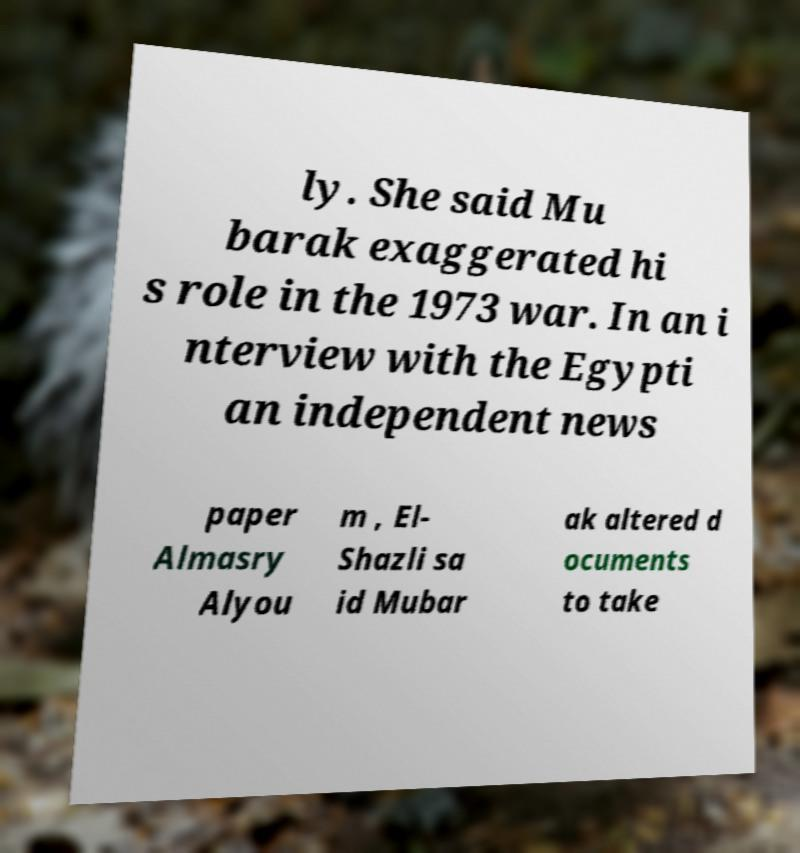I need the written content from this picture converted into text. Can you do that? ly. She said Mu barak exaggerated hi s role in the 1973 war. In an i nterview with the Egypti an independent news paper Almasry Alyou m , El- Shazli sa id Mubar ak altered d ocuments to take 